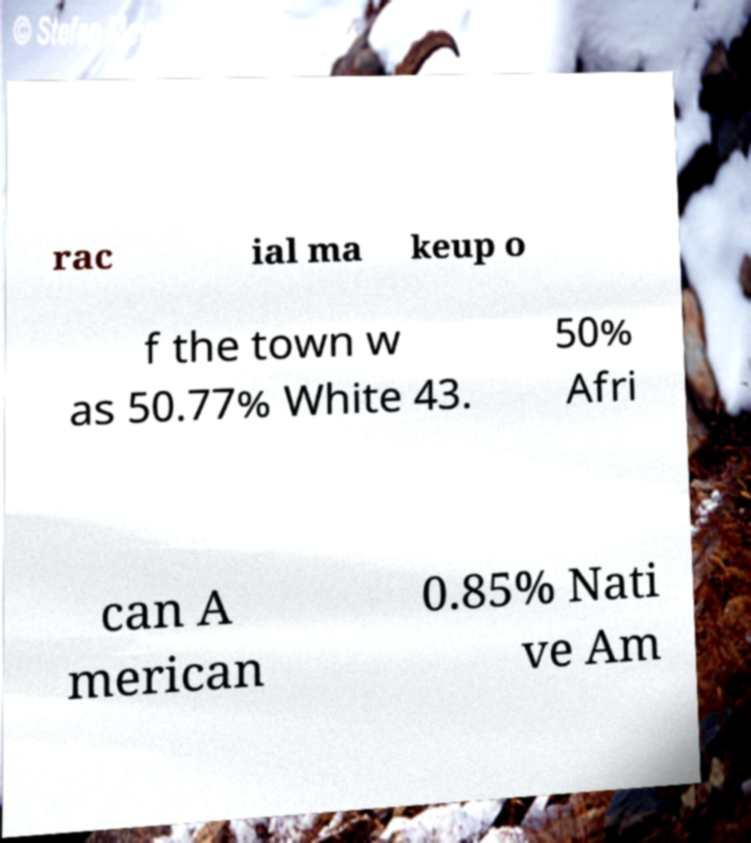Please identify and transcribe the text found in this image. rac ial ma keup o f the town w as 50.77% White 43. 50% Afri can A merican 0.85% Nati ve Am 